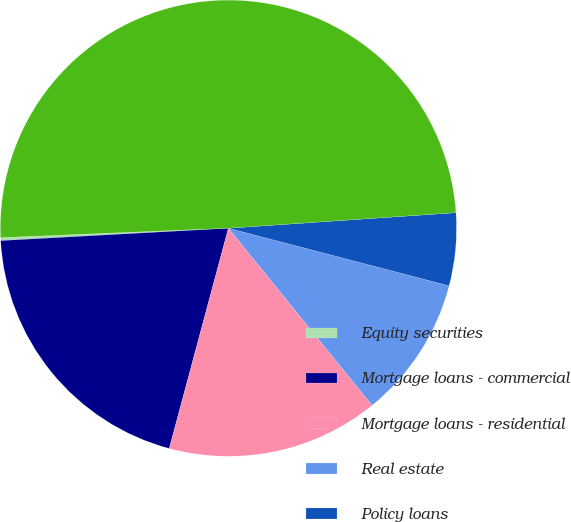<chart> <loc_0><loc_0><loc_500><loc_500><pie_chart><fcel>Equity securities<fcel>Mortgage loans - commercial<fcel>Mortgage loans - residential<fcel>Real estate<fcel>Policy loans<fcel>Total before investment<nl><fcel>0.21%<fcel>19.96%<fcel>15.02%<fcel>10.09%<fcel>5.15%<fcel>49.57%<nl></chart> 